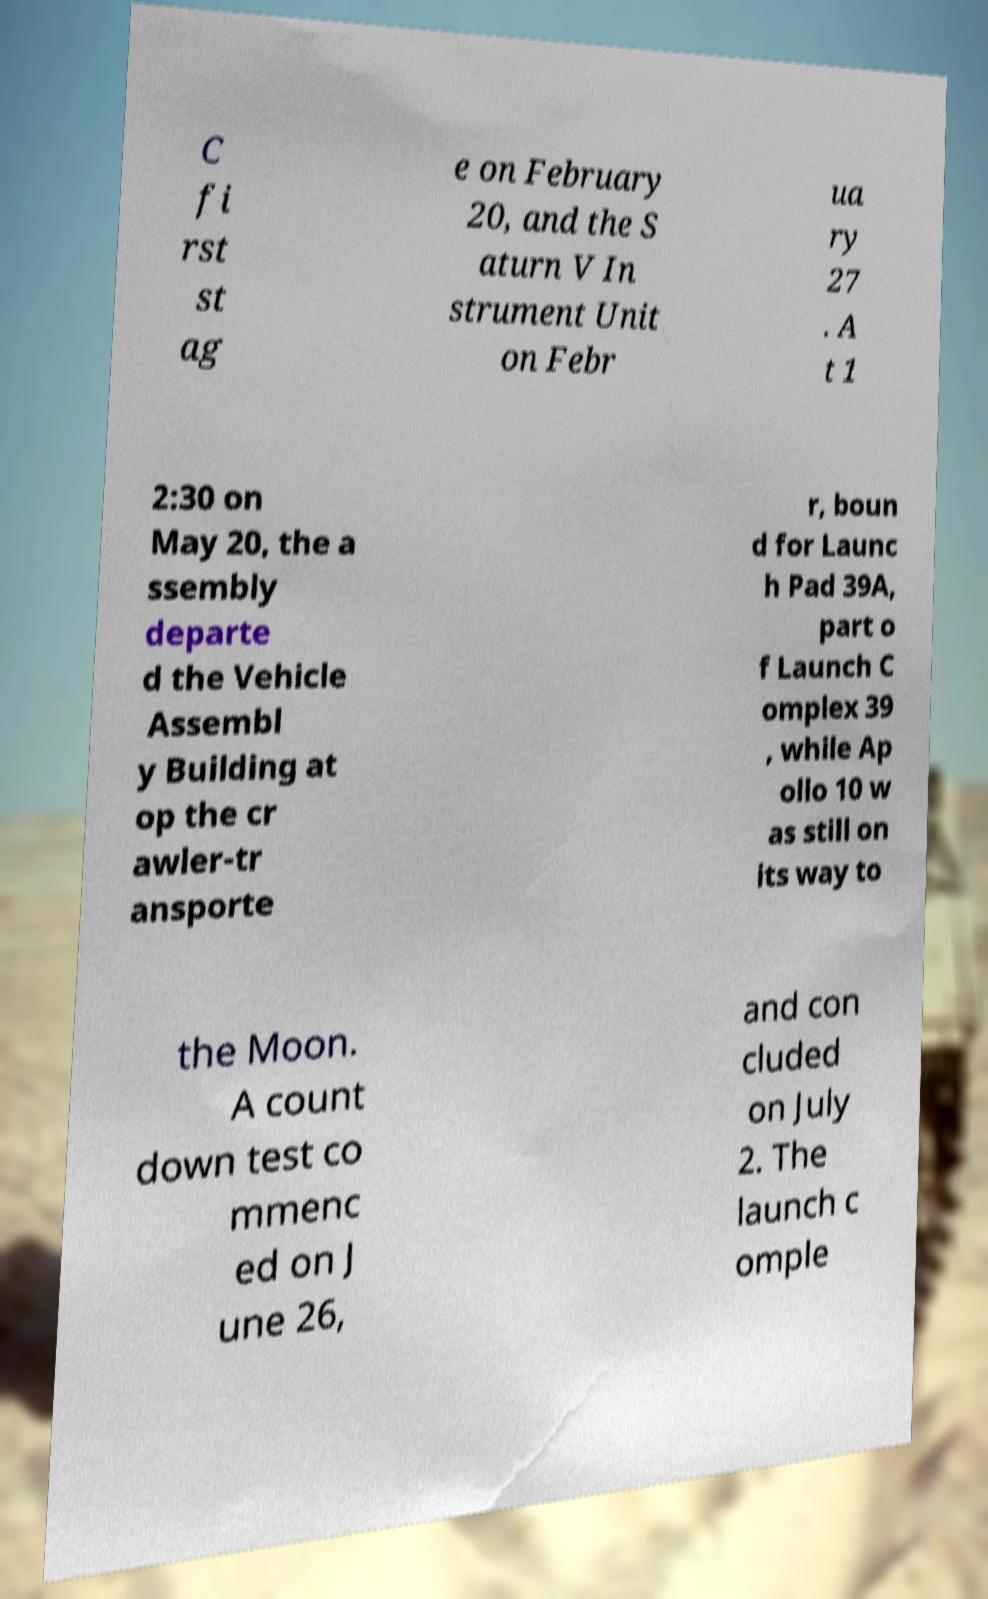There's text embedded in this image that I need extracted. Can you transcribe it verbatim? C fi rst st ag e on February 20, and the S aturn V In strument Unit on Febr ua ry 27 . A t 1 2:30 on May 20, the a ssembly departe d the Vehicle Assembl y Building at op the cr awler-tr ansporte r, boun d for Launc h Pad 39A, part o f Launch C omplex 39 , while Ap ollo 10 w as still on its way to the Moon. A count down test co mmenc ed on J une 26, and con cluded on July 2. The launch c omple 